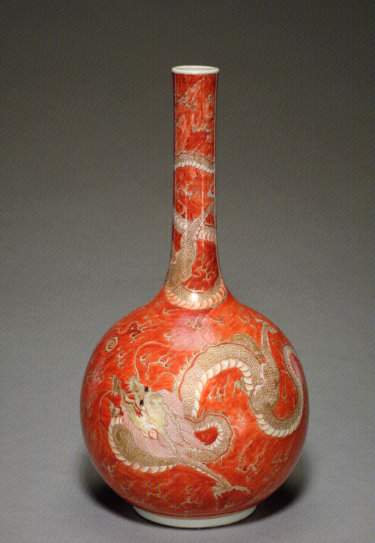该图包含什么文物，出自哪里 这件文物是一件中国瓷瓶，装饰着龙的图案，并涂有铁红色釉。 它很可能起源于中国景德镇窑，可追溯至清朝 18 世纪。

为了更准确地识别，可以咨询艺术史学家或专门研究中国瓷器的博物馆。 